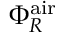Convert formula to latex. <formula><loc_0><loc_0><loc_500><loc_500>\Phi _ { R } ^ { a i r }</formula> 